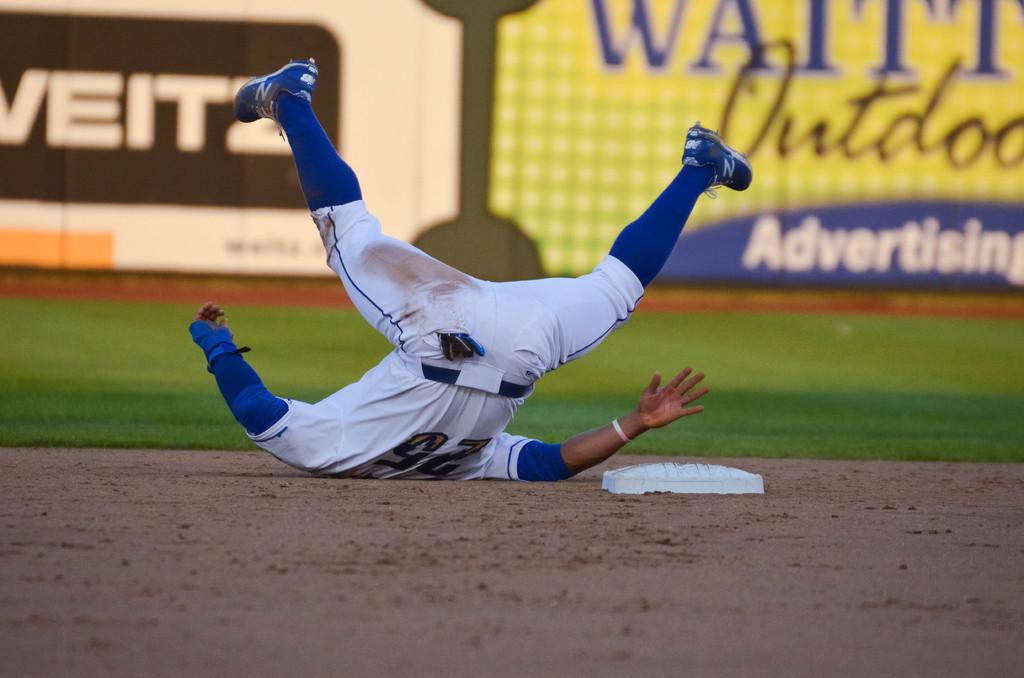<image>
Share a concise interpretation of the image provided. The player who has just fallen on their back is wearing number 25. 